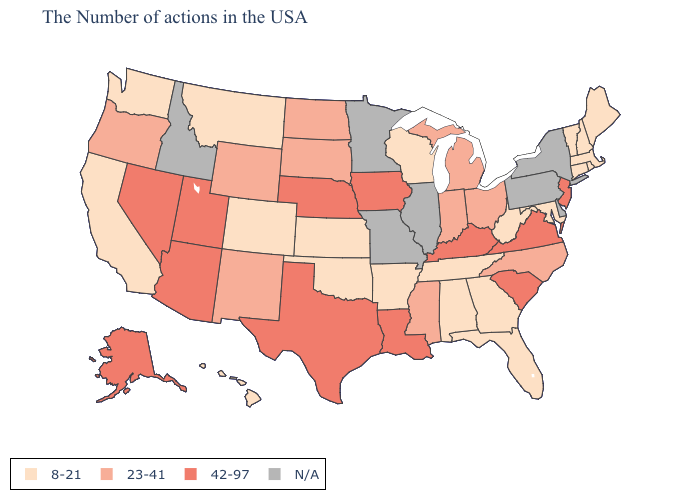Name the states that have a value in the range 8-21?
Answer briefly. Maine, Massachusetts, Rhode Island, New Hampshire, Vermont, Connecticut, Maryland, West Virginia, Florida, Georgia, Alabama, Tennessee, Wisconsin, Arkansas, Kansas, Oklahoma, Colorado, Montana, California, Washington, Hawaii. Among the states that border Arizona , which have the lowest value?
Keep it brief. Colorado, California. Does Iowa have the highest value in the MidWest?
Short answer required. Yes. What is the highest value in states that border Kansas?
Quick response, please. 42-97. Among the states that border Oregon , does Nevada have the highest value?
Quick response, please. Yes. What is the value of California?
Be succinct. 8-21. What is the highest value in the South ?
Concise answer only. 42-97. Does the first symbol in the legend represent the smallest category?
Keep it brief. Yes. What is the value of Arkansas?
Write a very short answer. 8-21. Among the states that border South Carolina , which have the highest value?
Give a very brief answer. North Carolina. Does the first symbol in the legend represent the smallest category?
Give a very brief answer. Yes. Among the states that border Delaware , which have the lowest value?
Give a very brief answer. Maryland. Name the states that have a value in the range 42-97?
Give a very brief answer. New Jersey, Virginia, South Carolina, Kentucky, Louisiana, Iowa, Nebraska, Texas, Utah, Arizona, Nevada, Alaska. 